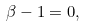Convert formula to latex. <formula><loc_0><loc_0><loc_500><loc_500>\beta - 1 = 0 ,</formula> 